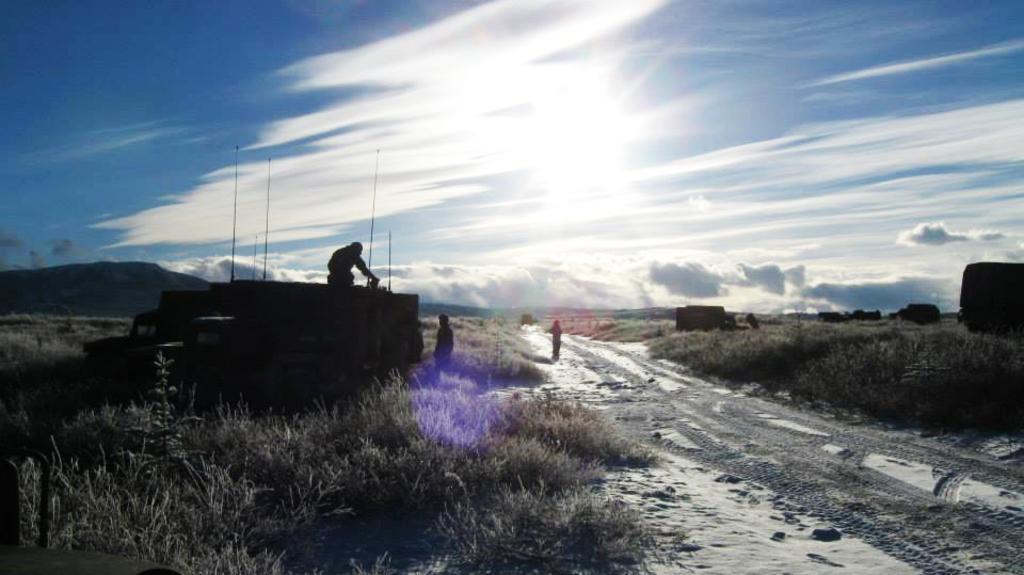Could you give a brief overview of what you see in this image? In this image there is a way on the right side. On the left side there is grass. Beside the grass there is a truck. On the truck there is a person. At the top there is the sky. On the way there is a person. 